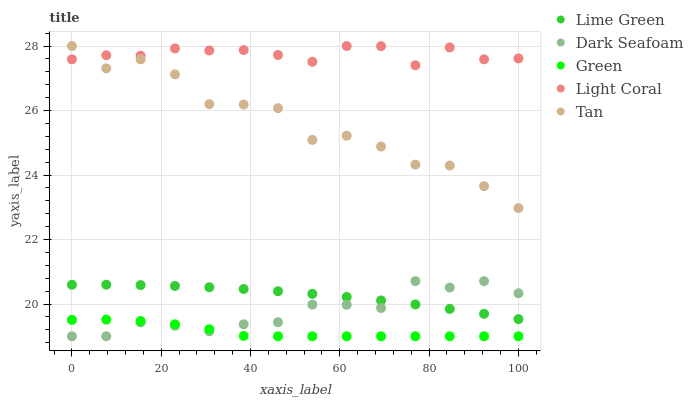Does Green have the minimum area under the curve?
Answer yes or no. Yes. Does Light Coral have the maximum area under the curve?
Answer yes or no. Yes. Does Dark Seafoam have the minimum area under the curve?
Answer yes or no. No. Does Dark Seafoam have the maximum area under the curve?
Answer yes or no. No. Is Lime Green the smoothest?
Answer yes or no. Yes. Is Tan the roughest?
Answer yes or no. Yes. Is Green the smoothest?
Answer yes or no. No. Is Green the roughest?
Answer yes or no. No. Does Green have the lowest value?
Answer yes or no. Yes. Does Lime Green have the lowest value?
Answer yes or no. No. Does Tan have the highest value?
Answer yes or no. Yes. Does Dark Seafoam have the highest value?
Answer yes or no. No. Is Dark Seafoam less than Tan?
Answer yes or no. Yes. Is Light Coral greater than Dark Seafoam?
Answer yes or no. Yes. Does Dark Seafoam intersect Lime Green?
Answer yes or no. Yes. Is Dark Seafoam less than Lime Green?
Answer yes or no. No. Is Dark Seafoam greater than Lime Green?
Answer yes or no. No. Does Dark Seafoam intersect Tan?
Answer yes or no. No. 